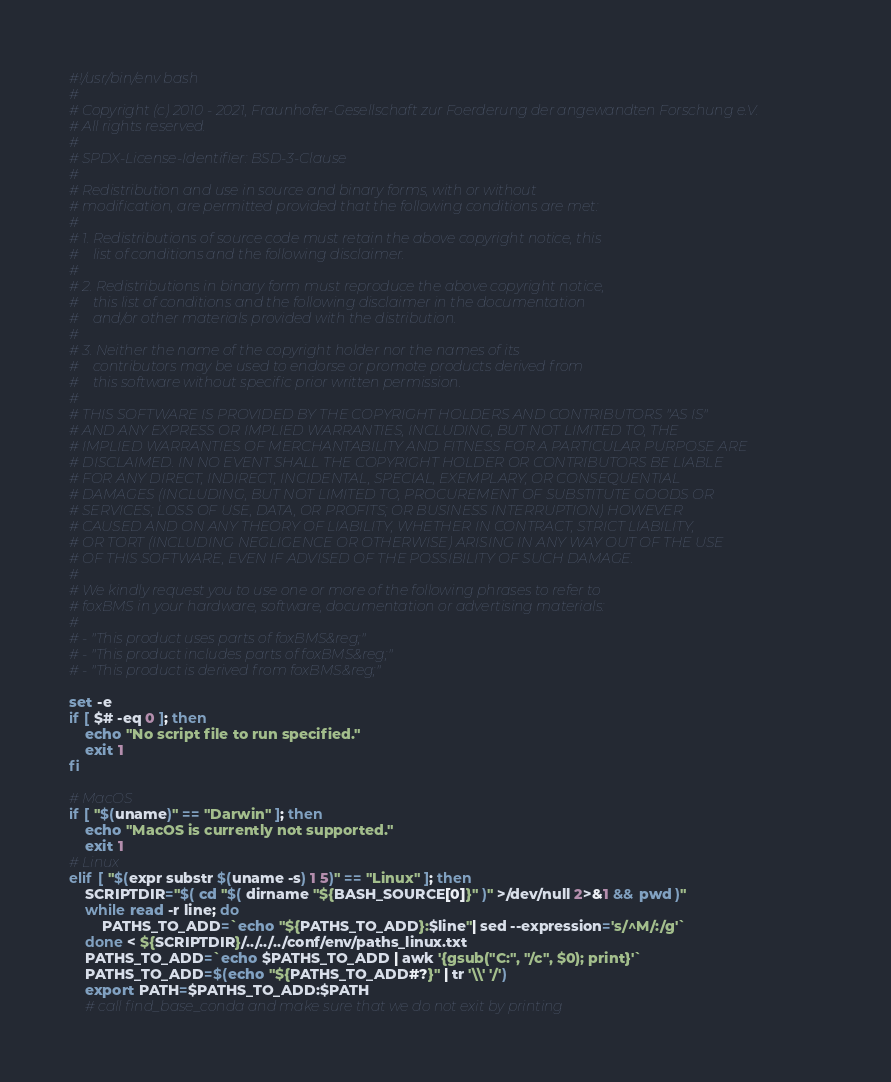Convert code to text. <code><loc_0><loc_0><loc_500><loc_500><_Bash_>#!/usr/bin/env bash
#
# Copyright (c) 2010 - 2021, Fraunhofer-Gesellschaft zur Foerderung der angewandten Forschung e.V.
# All rights reserved.
#
# SPDX-License-Identifier: BSD-3-Clause
#
# Redistribution and use in source and binary forms, with or without
# modification, are permitted provided that the following conditions are met:
#
# 1. Redistributions of source code must retain the above copyright notice, this
#    list of conditions and the following disclaimer.
#
# 2. Redistributions in binary form must reproduce the above copyright notice,
#    this list of conditions and the following disclaimer in the documentation
#    and/or other materials provided with the distribution.
#
# 3. Neither the name of the copyright holder nor the names of its
#    contributors may be used to endorse or promote products derived from
#    this software without specific prior written permission.
#
# THIS SOFTWARE IS PROVIDED BY THE COPYRIGHT HOLDERS AND CONTRIBUTORS "AS IS"
# AND ANY EXPRESS OR IMPLIED WARRANTIES, INCLUDING, BUT NOT LIMITED TO, THE
# IMPLIED WARRANTIES OF MERCHANTABILITY AND FITNESS FOR A PARTICULAR PURPOSE ARE
# DISCLAIMED. IN NO EVENT SHALL THE COPYRIGHT HOLDER OR CONTRIBUTORS BE LIABLE
# FOR ANY DIRECT, INDIRECT, INCIDENTAL, SPECIAL, EXEMPLARY, OR CONSEQUENTIAL
# DAMAGES (INCLUDING, BUT NOT LIMITED TO, PROCUREMENT OF SUBSTITUTE GOODS OR
# SERVICES; LOSS OF USE, DATA, OR PROFITS; OR BUSINESS INTERRUPTION) HOWEVER
# CAUSED AND ON ANY THEORY OF LIABILITY, WHETHER IN CONTRACT, STRICT LIABILITY,
# OR TORT (INCLUDING NEGLIGENCE OR OTHERWISE) ARISING IN ANY WAY OUT OF THE USE
# OF THIS SOFTWARE, EVEN IF ADVISED OF THE POSSIBILITY OF SUCH DAMAGE.
#
# We kindly request you to use one or more of the following phrases to refer to
# foxBMS in your hardware, software, documentation or advertising materials:
#
# - "This product uses parts of foxBMS&reg;"
# - "This product includes parts of foxBMS&reg;"
# - "This product is derived from foxBMS&reg;"

set -e
if [ $# -eq 0 ]; then
    echo "No script file to run specified."
    exit 1
fi

# MacOS
if [ "$(uname)" == "Darwin" ]; then
    echo "MacOS is currently not supported."
    exit 1
# Linux
elif [ "$(expr substr $(uname -s) 1 5)" == "Linux" ]; then
    SCRIPTDIR="$( cd "$( dirname "${BASH_SOURCE[0]}" )" >/dev/null 2>&1 && pwd )"
    while read -r line; do
        PATHS_TO_ADD=`echo "${PATHS_TO_ADD}:$line"| sed --expression='s/^M/:/g'`
    done < ${SCRIPTDIR}/../../../conf/env/paths_linux.txt
    PATHS_TO_ADD=`echo $PATHS_TO_ADD | awk '{gsub("C:", "/c", $0); print}'`
    PATHS_TO_ADD=$(echo "${PATHS_TO_ADD#?}" | tr '\\' '/')
    export PATH=$PATHS_TO_ADD:$PATH
    # call find_base_conda and make sure that we do not exit by printing</code> 